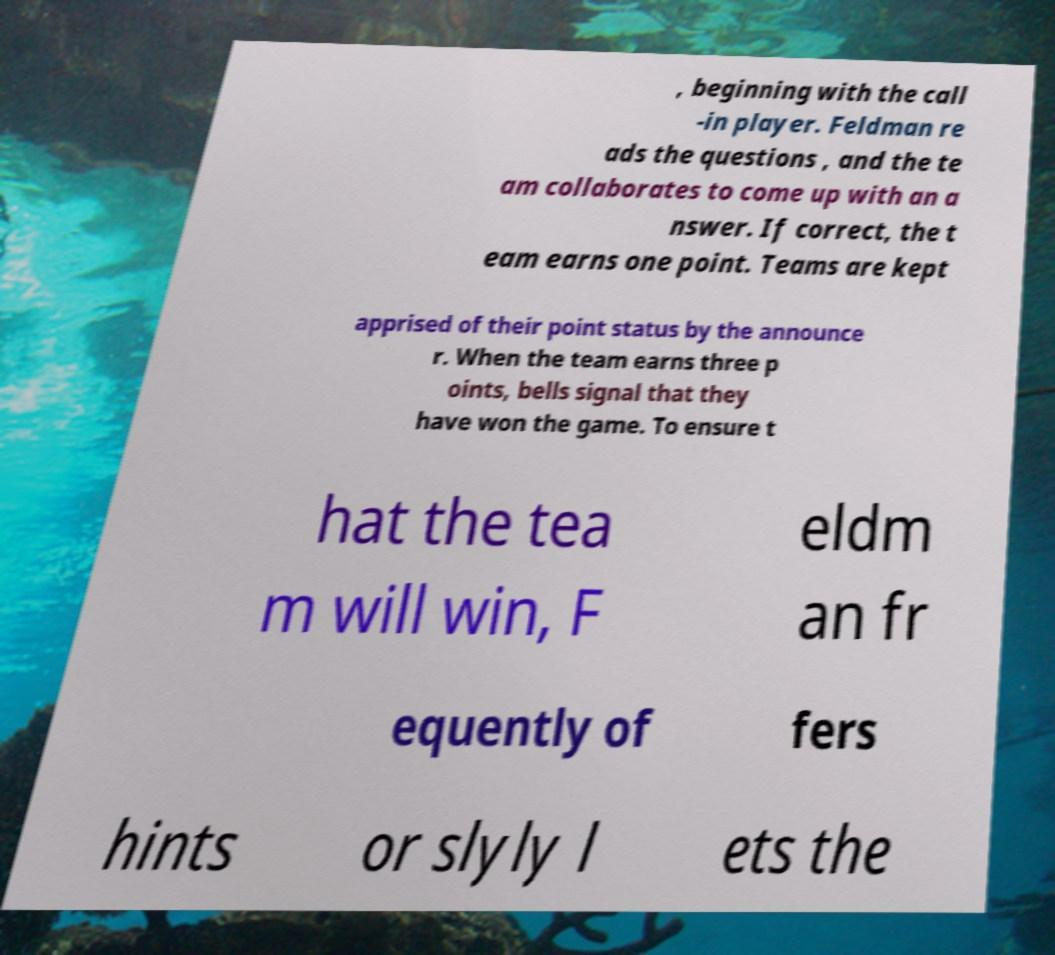I need the written content from this picture converted into text. Can you do that? , beginning with the call -in player. Feldman re ads the questions , and the te am collaborates to come up with an a nswer. If correct, the t eam earns one point. Teams are kept apprised of their point status by the announce r. When the team earns three p oints, bells signal that they have won the game. To ensure t hat the tea m will win, F eldm an fr equently of fers hints or slyly l ets the 